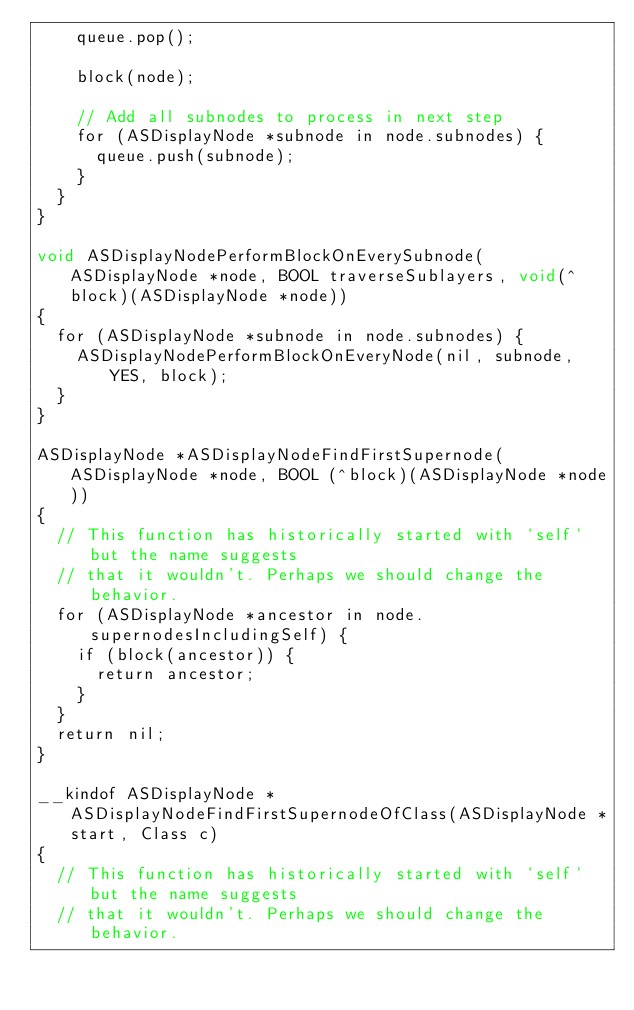<code> <loc_0><loc_0><loc_500><loc_500><_ObjectiveC_>    queue.pop();
    
    block(node);

    // Add all subnodes to process in next step
    for (ASDisplayNode *subnode in node.subnodes) {
      queue.push(subnode);
    }
  }
}

void ASDisplayNodePerformBlockOnEverySubnode(ASDisplayNode *node, BOOL traverseSublayers, void(^block)(ASDisplayNode *node))
{
  for (ASDisplayNode *subnode in node.subnodes) {
    ASDisplayNodePerformBlockOnEveryNode(nil, subnode, YES, block);
  }
}

ASDisplayNode *ASDisplayNodeFindFirstSupernode(ASDisplayNode *node, BOOL (^block)(ASDisplayNode *node))
{
  // This function has historically started with `self` but the name suggests
  // that it wouldn't. Perhaps we should change the behavior.
  for (ASDisplayNode *ancestor in node.supernodesIncludingSelf) {
    if (block(ancestor)) {
      return ancestor;
    }
  }
  return nil;
}

__kindof ASDisplayNode *ASDisplayNodeFindFirstSupernodeOfClass(ASDisplayNode *start, Class c)
{
  // This function has historically started with `self` but the name suggests
  // that it wouldn't. Perhaps we should change the behavior.</code> 